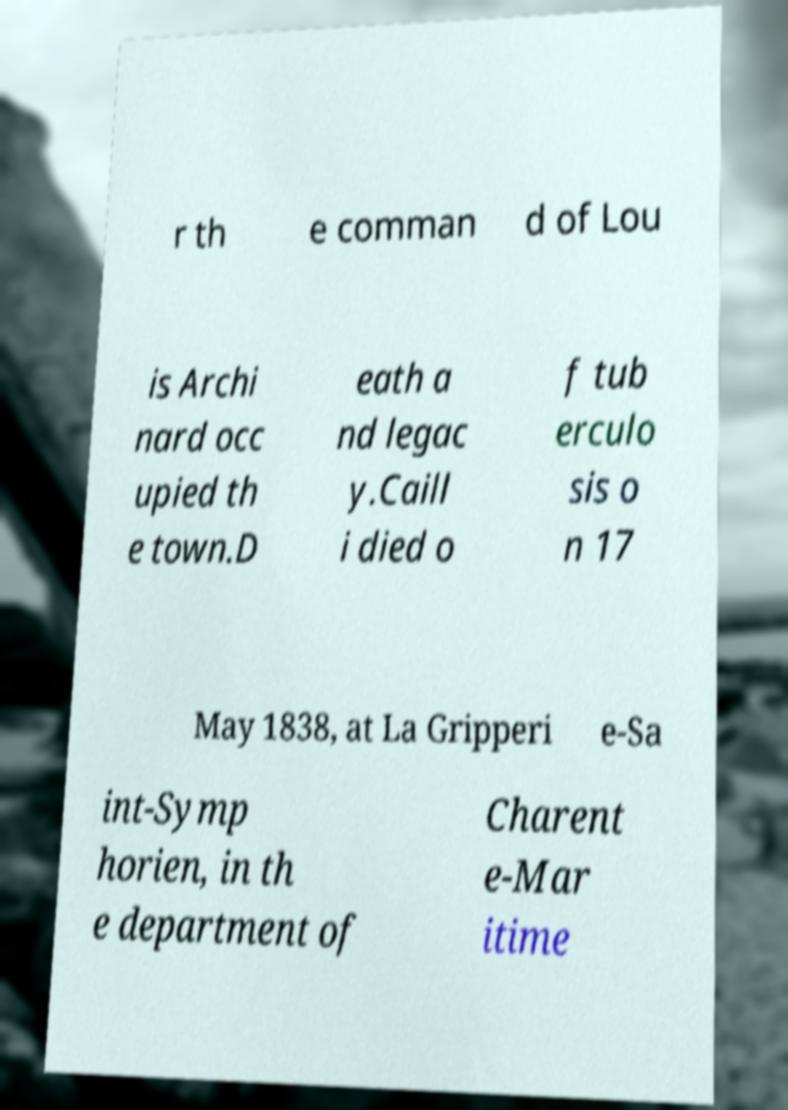Could you assist in decoding the text presented in this image and type it out clearly? r th e comman d of Lou is Archi nard occ upied th e town.D eath a nd legac y.Caill i died o f tub erculo sis o n 17 May 1838, at La Gripperi e-Sa int-Symp horien, in th e department of Charent e-Mar itime 